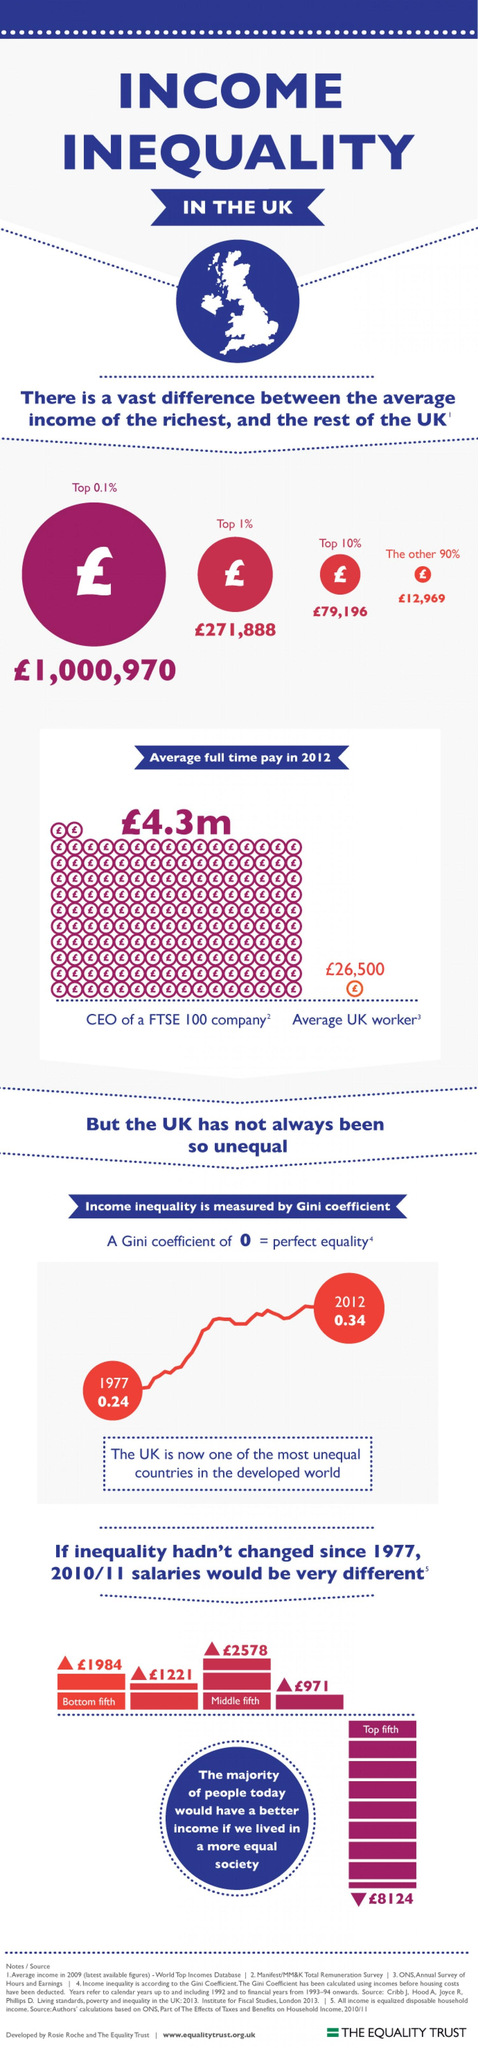Draw attention to some important aspects in this diagram. The Gini coefficient increased by 0.14 points from 1977 to 2012. The average income in pounds for the top 10% is approximately 79,196 pounds per year. The average full-time worker in the UK earns a salary of approximately 26,500 pounds per year. 